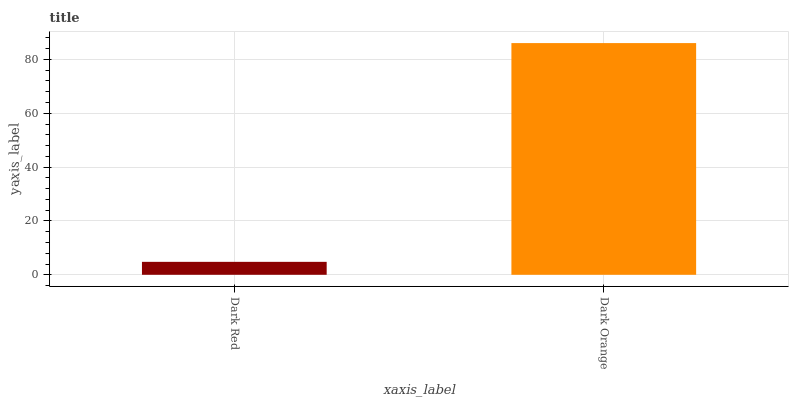Is Dark Red the minimum?
Answer yes or no. Yes. Is Dark Orange the maximum?
Answer yes or no. Yes. Is Dark Orange the minimum?
Answer yes or no. No. Is Dark Orange greater than Dark Red?
Answer yes or no. Yes. Is Dark Red less than Dark Orange?
Answer yes or no. Yes. Is Dark Red greater than Dark Orange?
Answer yes or no. No. Is Dark Orange less than Dark Red?
Answer yes or no. No. Is Dark Orange the high median?
Answer yes or no. Yes. Is Dark Red the low median?
Answer yes or no. Yes. Is Dark Red the high median?
Answer yes or no. No. Is Dark Orange the low median?
Answer yes or no. No. 